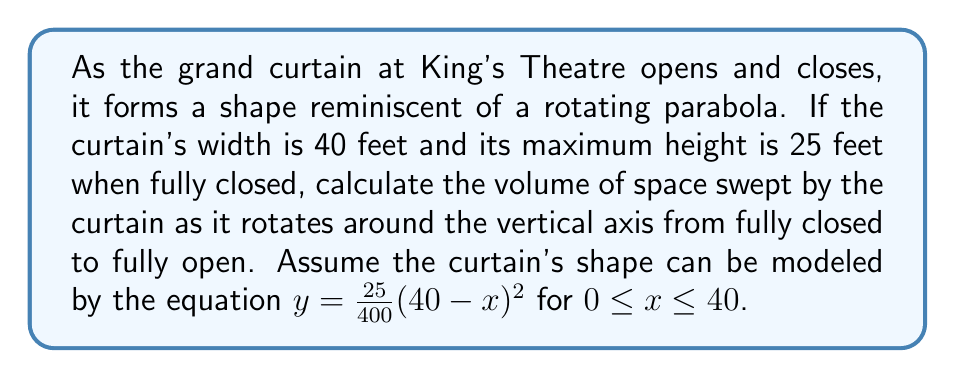Show me your answer to this math problem. To solve this problem, we'll use the method of rotating a function around the y-axis to find the volume. The steps are as follows:

1) The volume of a solid formed by rotating a region bounded by $y = f(x)$, the x-axis, and the lines $x = a$ and $x = b$ around the y-axis is given by:

   $$V = 2\pi \int_a^b xf(x)dx$$

2) In our case, $f(x) = \frac{25}{400}(40-x)^2$, $a = 0$, and $b = 40$.

3) Substituting into the volume formula:

   $$V = 2\pi \int_0^{40} x\cdot\frac{25}{400}(40-x)^2dx$$

4) Simplifying the integrand:

   $$V = \frac{\pi}{8} \int_0^{40} x(40-x)^2dx$$

5) Expanding $(40-x)^2$:

   $$V = \frac{\pi}{8} \int_0^{40} x(1600-80x+x^2)dx$$

6) Distributing $x$:

   $$V = \frac{\pi}{8} \int_0^{40} (1600x-80x^2+x^3)dx$$

7) Integrating:

   $$V = \frac{\pi}{8} \left[800x^2-\frac{80}{3}x^3+\frac{1}{4}x^4\right]_0^{40}$$

8) Evaluating the definite integral:

   $$V = \frac{\pi}{8} \left[(800\cdot1600-\frac{80}{3}\cdot64000+\frac{1}{4}\cdot2560000) - (0)\right]$$

9) Simplifying:

   $$V = \frac{\pi}{8} (1280000-1706666.67+640000) = \frac{\pi}{8} \cdot 213333.33$$

10) Final calculation:

    $$V = 83733.33\pi \approx 262933.33 \text{ cubic feet}$$
Answer: $83733.33\pi$ cubic feet 